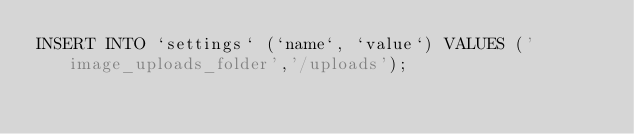Convert code to text. <code><loc_0><loc_0><loc_500><loc_500><_SQL_>INSERT INTO `settings` (`name`, `value`) VALUES ('image_uploads_folder','/uploads');
</code> 